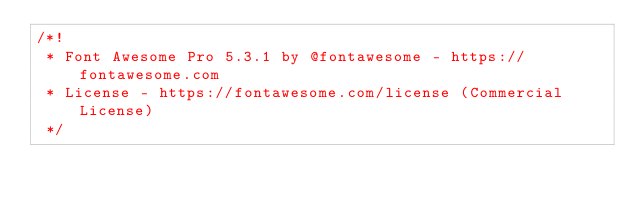Convert code to text. <code><loc_0><loc_0><loc_500><loc_500><_CSS_>/*!
 * Font Awesome Pro 5.3.1 by @fontawesome - https://fontawesome.com
 * License - https://fontawesome.com/license (Commercial License)
 */</code> 